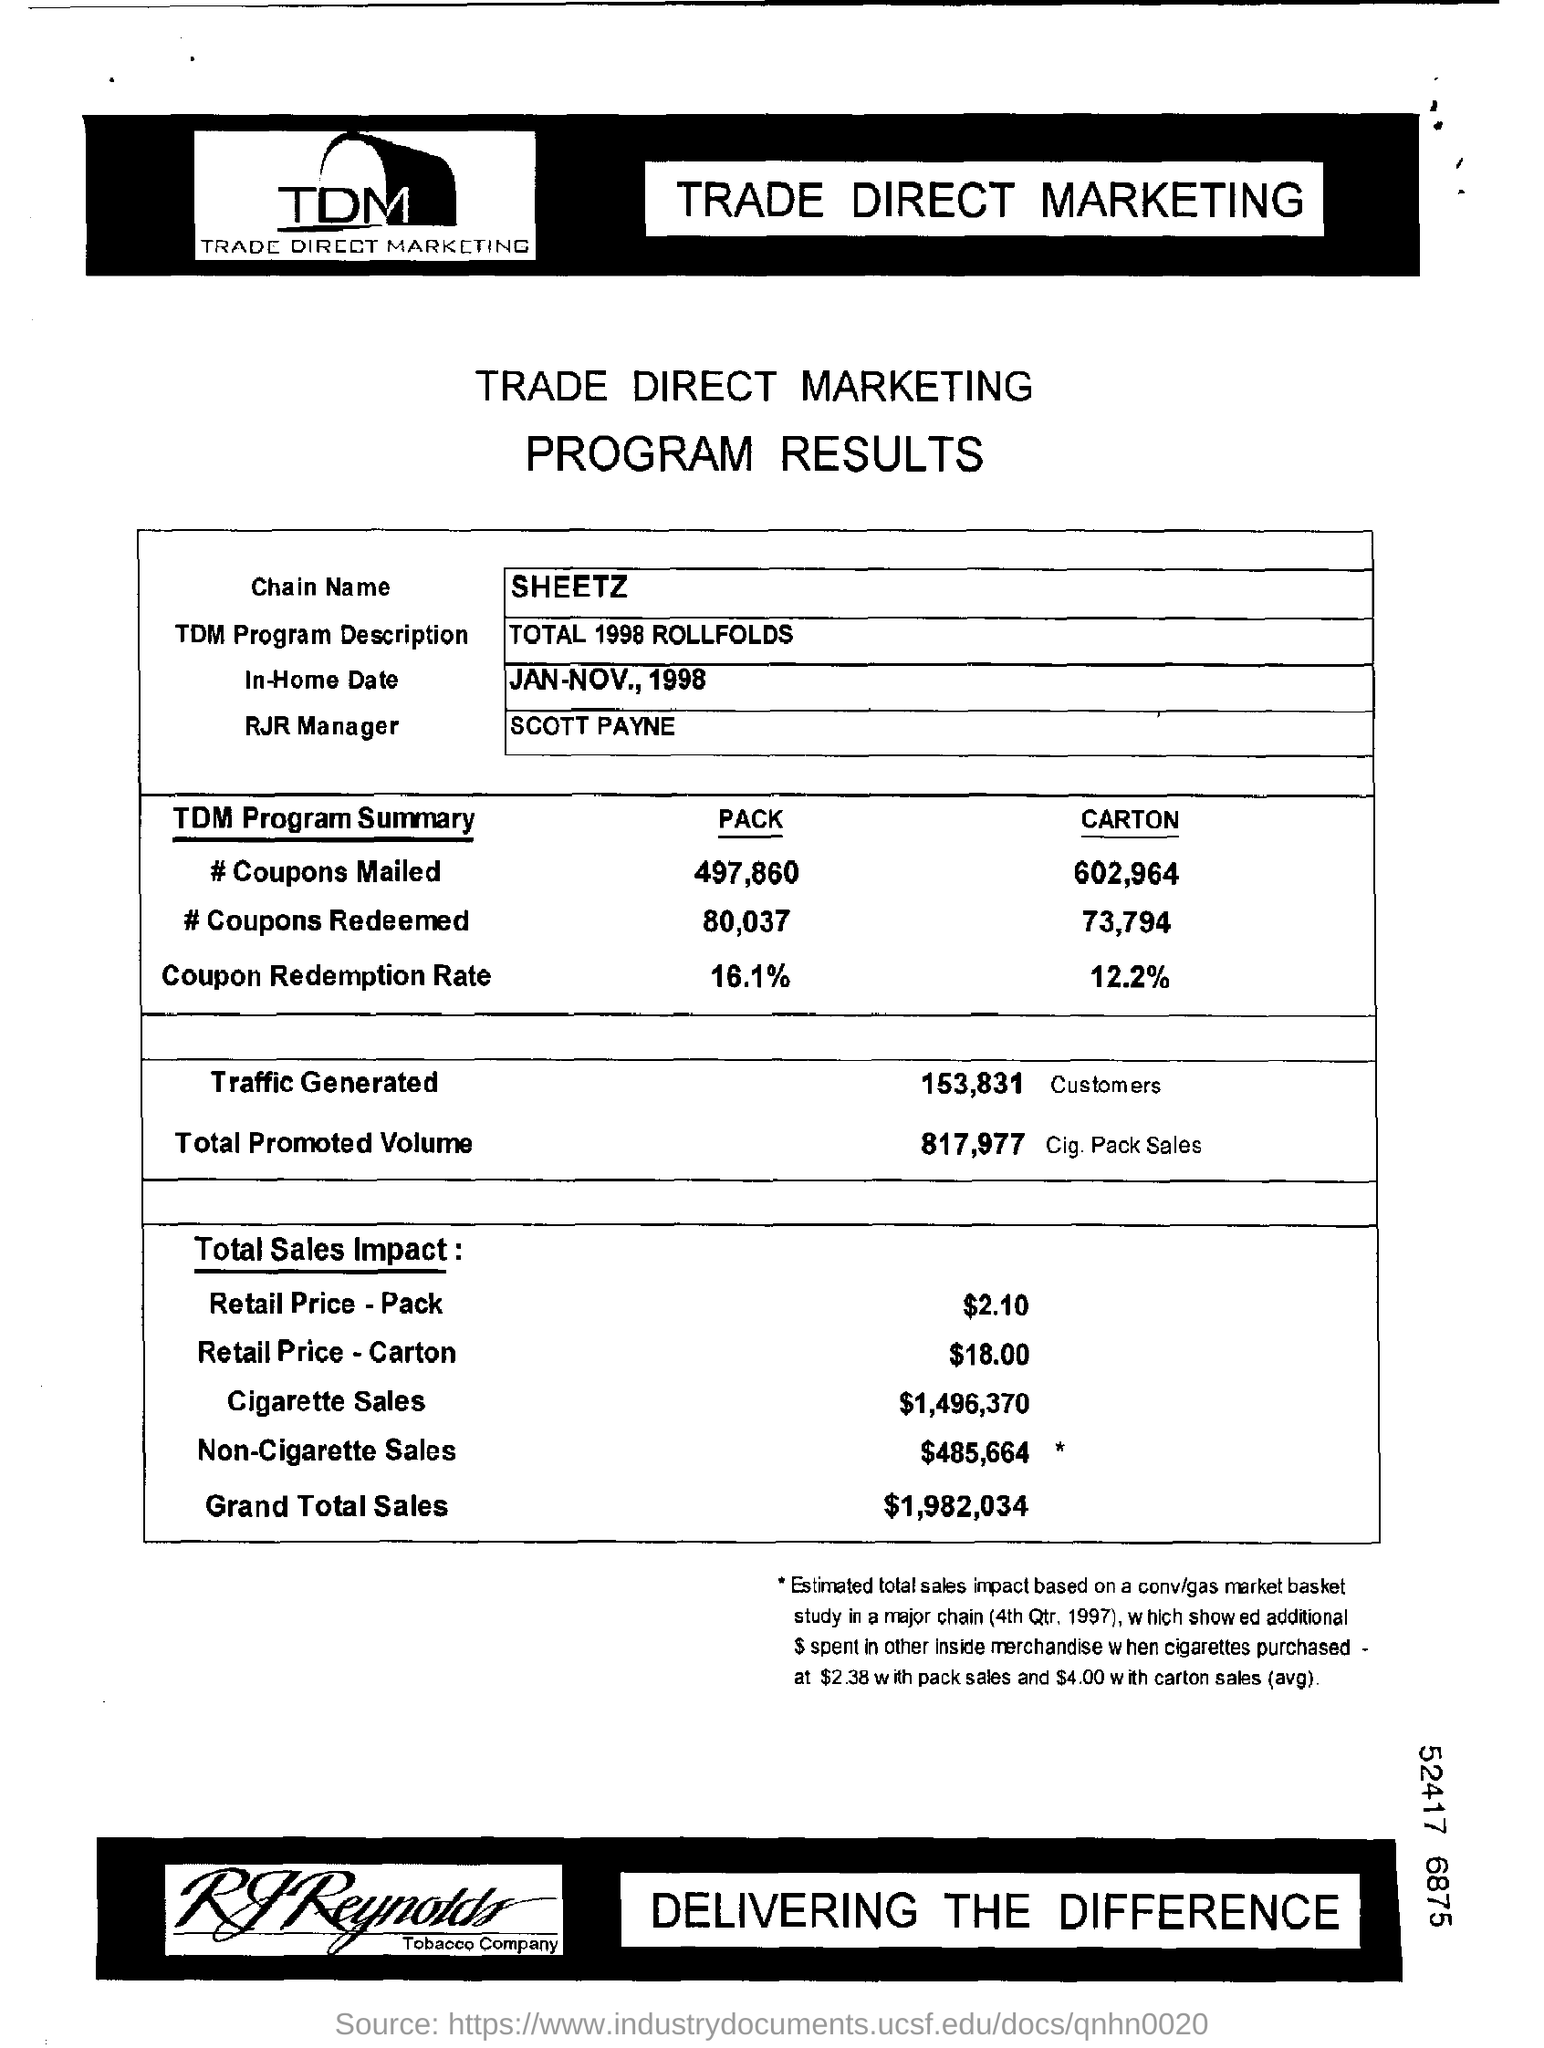Identify some key points in this picture. The amount of cigarette sales is $1,496,370. Of the traffic generated, 153,831 customers have been identified. The grand total sales for the "total sales impact" are $1,982,034. The in-home date ranges from January to November of 1998. The total promoted volume is 817,977. 